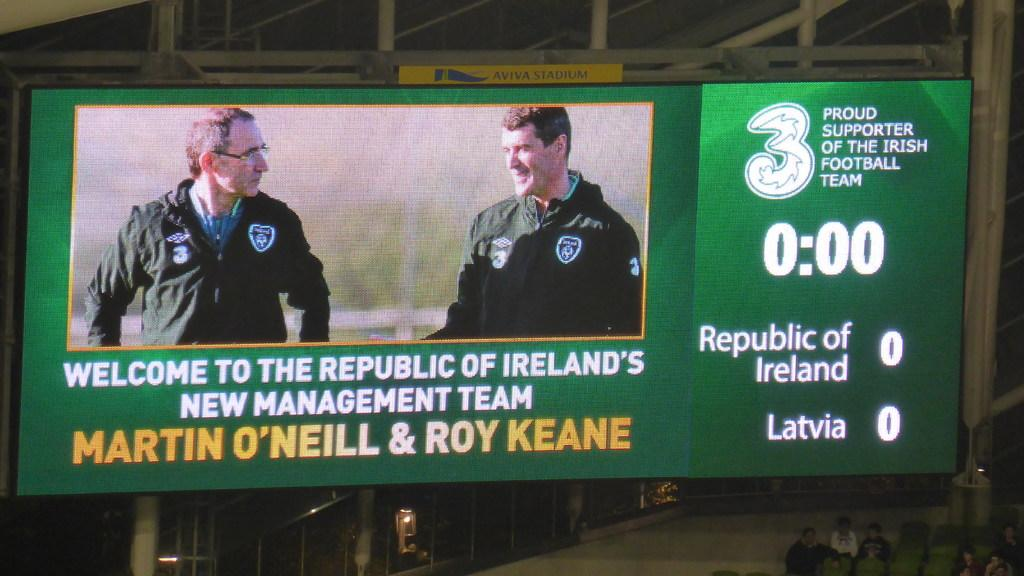<image>
Render a clear and concise summary of the photo. Ireland's national football team welcomes two into the new management team. 